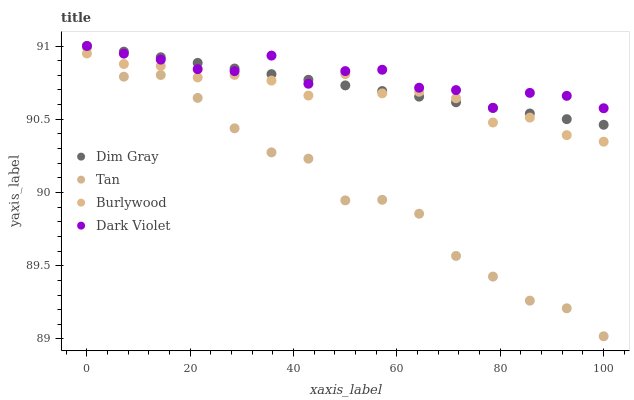Does Tan have the minimum area under the curve?
Answer yes or no. Yes. Does Dark Violet have the maximum area under the curve?
Answer yes or no. Yes. Does Dim Gray have the minimum area under the curve?
Answer yes or no. No. Does Dim Gray have the maximum area under the curve?
Answer yes or no. No. Is Dim Gray the smoothest?
Answer yes or no. Yes. Is Tan the roughest?
Answer yes or no. Yes. Is Tan the smoothest?
Answer yes or no. No. Is Dim Gray the roughest?
Answer yes or no. No. Does Tan have the lowest value?
Answer yes or no. Yes. Does Dim Gray have the lowest value?
Answer yes or no. No. Does Dark Violet have the highest value?
Answer yes or no. Yes. Does Tan have the highest value?
Answer yes or no. No. Is Tan less than Dark Violet?
Answer yes or no. Yes. Is Dim Gray greater than Tan?
Answer yes or no. Yes. Does Dark Violet intersect Dim Gray?
Answer yes or no. Yes. Is Dark Violet less than Dim Gray?
Answer yes or no. No. Is Dark Violet greater than Dim Gray?
Answer yes or no. No. Does Tan intersect Dark Violet?
Answer yes or no. No. 